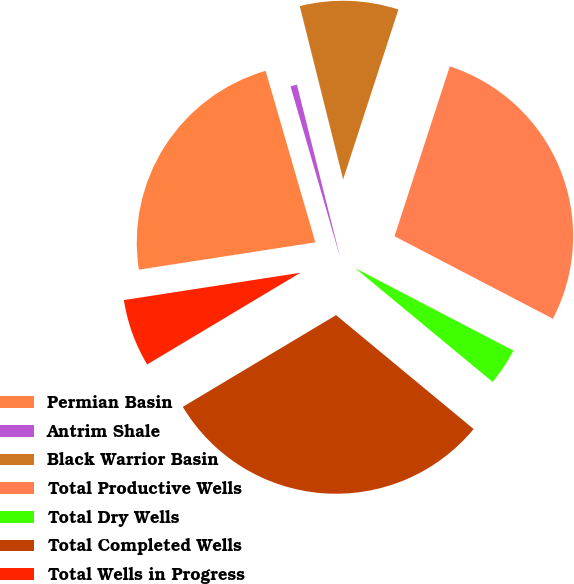Convert chart. <chart><loc_0><loc_0><loc_500><loc_500><pie_chart><fcel>Permian Basin<fcel>Antrim Shale<fcel>Black Warrior Basin<fcel>Total Productive Wells<fcel>Total Dry Wells<fcel>Total Completed Wells<fcel>Total Wells in Progress<nl><fcel>22.95%<fcel>0.59%<fcel>8.91%<fcel>27.64%<fcel>3.36%<fcel>30.41%<fcel>6.14%<nl></chart> 